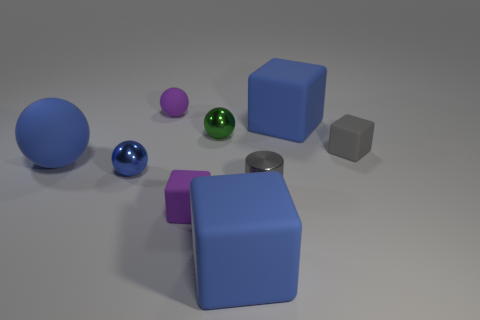What is the size of the blue sphere that is made of the same material as the small purple cube?
Offer a terse response. Large. What is the size of the matte ball that is in front of the big matte cube that is behind the small gray metallic cylinder?
Your answer should be very brief. Large. There is a block in front of the block that is to the left of the blue matte thing that is in front of the tiny purple matte cube; how big is it?
Provide a short and direct response. Large. Are there more small balls in front of the blue rubber ball than large green cubes?
Give a very brief answer. Yes. Is there a blue matte thing that has the same shape as the green metallic thing?
Provide a short and direct response. Yes. Does the gray cylinder have the same material as the tiny ball that is in front of the green object?
Your answer should be compact. Yes. What color is the small shiny cylinder?
Keep it short and to the point. Gray. What number of gray rubber blocks are left of the gray object to the left of the big blue matte thing that is behind the small green metal ball?
Provide a succinct answer. 0. There is a tiny purple ball; are there any purple balls behind it?
Your response must be concise. No. What number of things have the same material as the purple sphere?
Offer a terse response. 5. 